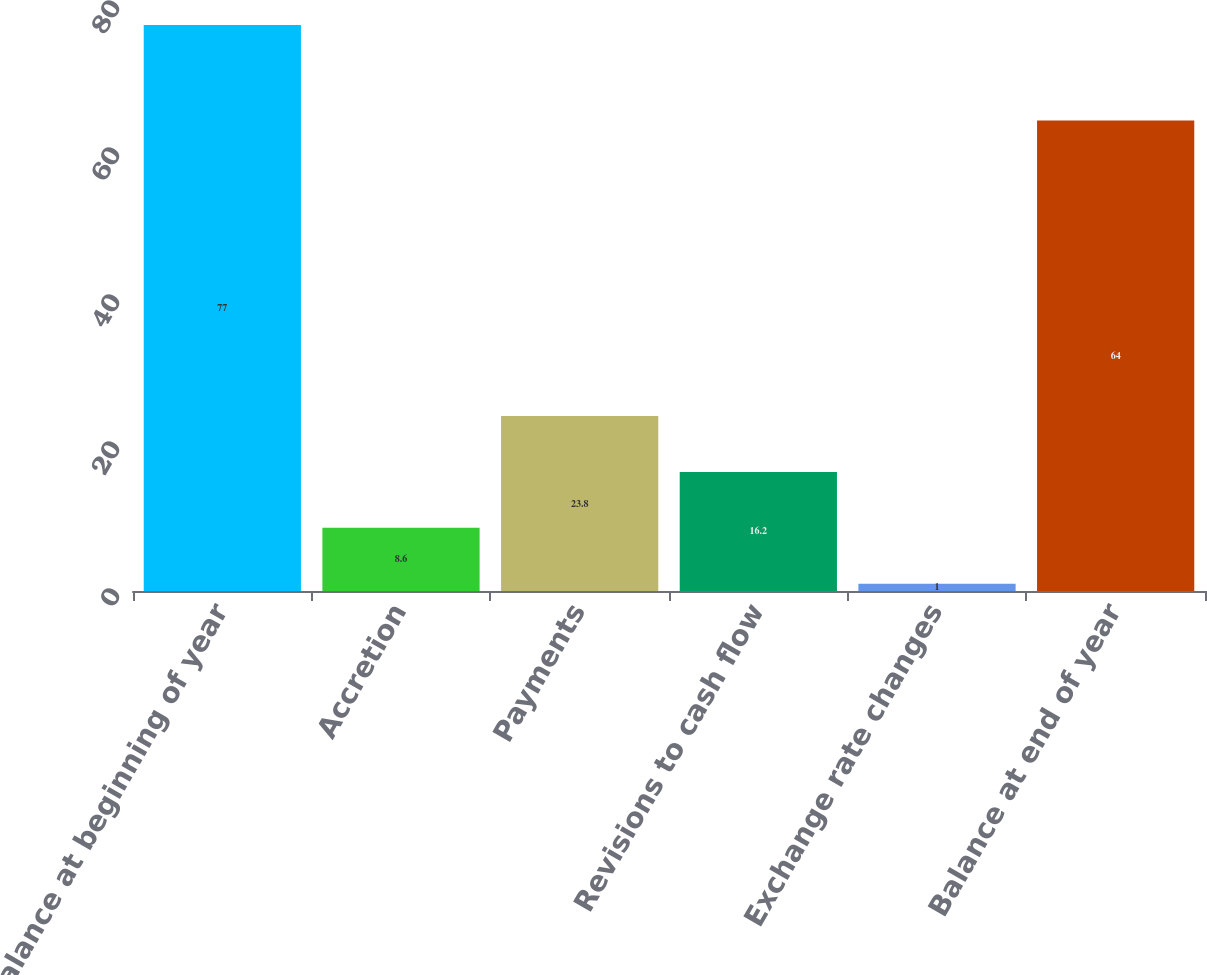<chart> <loc_0><loc_0><loc_500><loc_500><bar_chart><fcel>Balance at beginning of year<fcel>Accretion<fcel>Payments<fcel>Revisions to cash flow<fcel>Exchange rate changes<fcel>Balance at end of year<nl><fcel>77<fcel>8.6<fcel>23.8<fcel>16.2<fcel>1<fcel>64<nl></chart> 